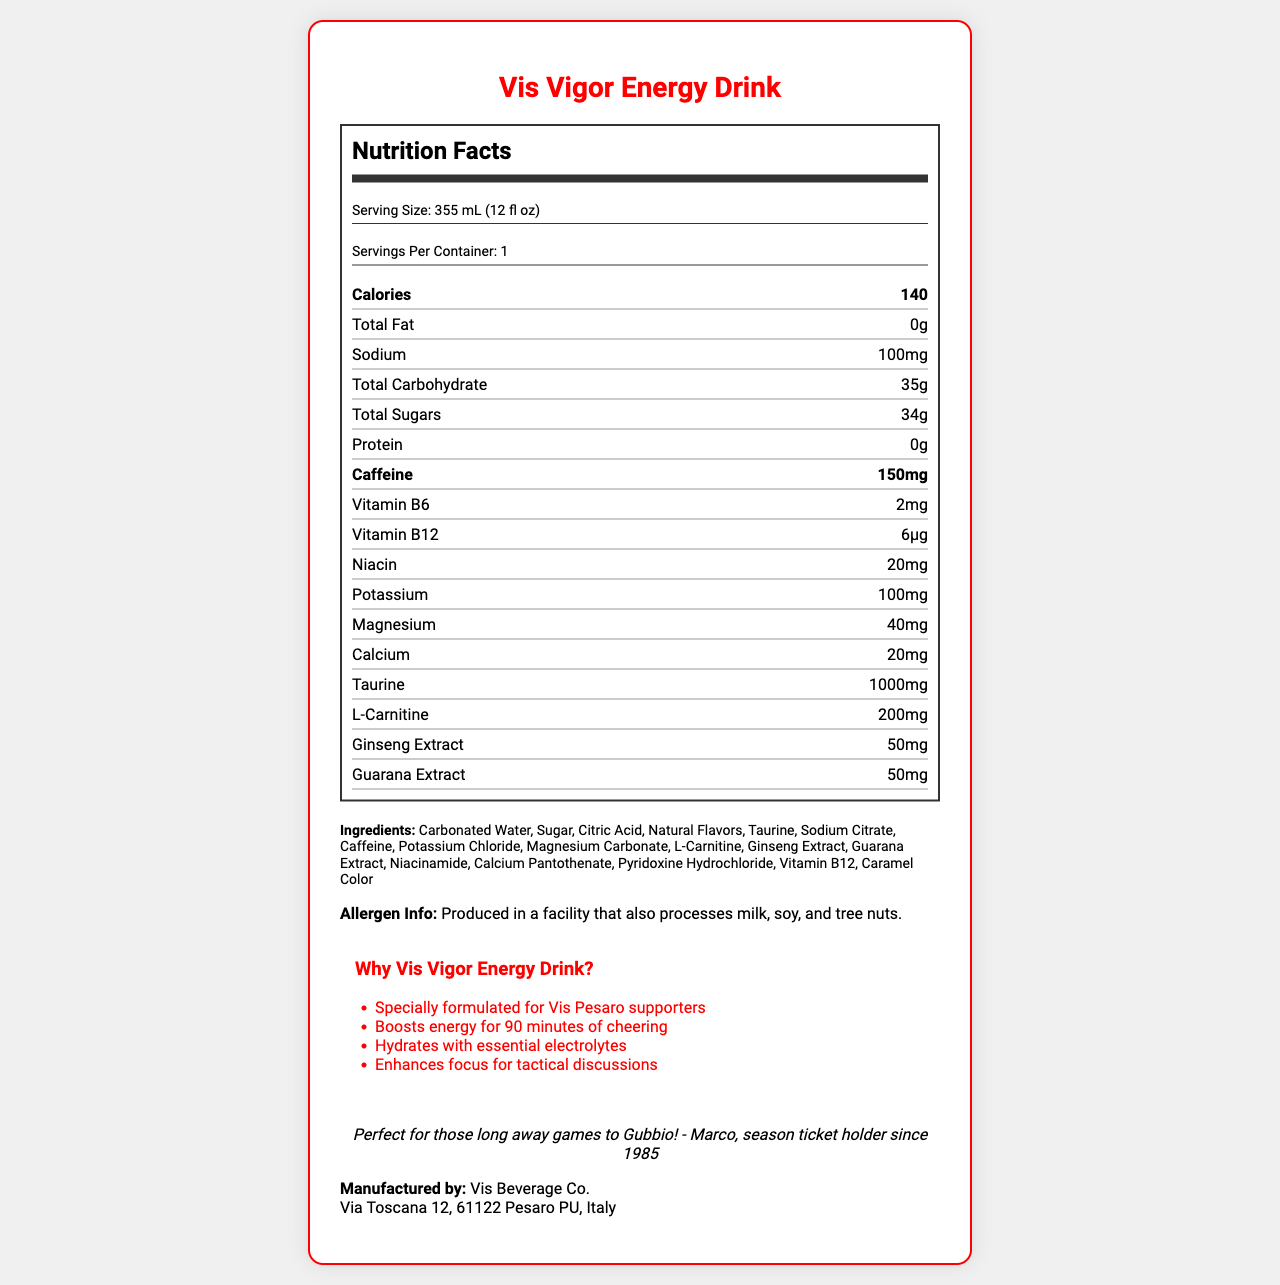What is the serving size of the Vis Vigor Energy Drink? The serving size is listed at the beginning of the Nutrition Facts section.
Answer: 355 mL (12 fl oz) How much caffeine is in one serving of Vis Vigor Energy Drink? The amount of caffeine is listed under the nutrient section.
Answer: 150mg What amount of sodium is in the Vis Vigor Energy Drink? The amount of sodium is listed under the nutrient section.
Answer: 100mg Who manufactures the Vis Vigor Energy Drink? The manufacturer information is provided at the end of the document.
Answer: Vis Beverage Co. What are the primary and secondary team colors for Vis Vigor Energy Drink? The team colors are listed under "team colors" in the data.
Answer: Red and White How many grams of total sugars are in one serving of Vis Vigor Energy Drink? A. 28g B. 30g C. 34g D. 40g The total sugar content is listed under the nutrient section as 34g.
Answer: C Which of the following ingredients are included in the Vis Vigor Energy Drink? I. Taurine II. Guarana Extract III. B Vitamins A. I only B. I and II only C. II and III only D. I, II, and III Taurine, Guarana Extract, and various B vitamins are all listed in the ingredients section.
Answer: D Does the Vis Vigor Energy Drink contain protein? The protein value is listed as 0g under the nutrient section.
Answer: No Can you summarize the key features and nutritional contents of the Vis Vigor Energy Drink? The document highlights the drink's attributes optimized for sports fans, including its nutritional content, benefits, ingredients, and manufacturing details.
Answer: The Vis Vigor Energy Drink is specially formulated for Vis Pesaro supporters and contains 140 calories per serving with 150mg of caffeine. It is designed to boost energy, hydrate with essential electrolytes, and enhance focus. The drink includes nutrients such as vitamin B6, vitamin B12, niacin, potassium, magnesium, and calcium and contains electrolytes like potassium and magnesium to keep supporters energized and hydrated. Ingredients include carbonated water, sugar, taurine, and various extracts and vitamins. It comes in team colors of red and white and is produced by Vis Beverage Co. What is the price of one Vis Vigor Energy Drink? The document does not provide any details about the price of the energy drink.
Answer: Not enough information 